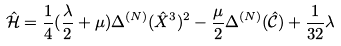<formula> <loc_0><loc_0><loc_500><loc_500>\hat { \mathcal { H } } = \frac { 1 } { 4 } ( \frac { \lambda } { 2 } + \mu ) \Delta ^ { ( N ) } ( \hat { X } ^ { 3 } ) ^ { 2 } - \frac { \mu } { 2 } \Delta ^ { ( N ) } ( \hat { \mathcal { C } } ) + \frac { 1 } { 3 2 } \lambda</formula> 